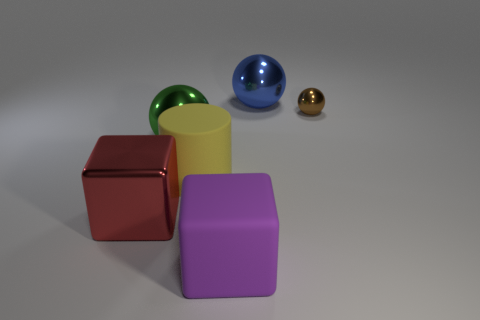How many blocks are either big things or yellow metal things?
Offer a terse response. 2. Is there any other thing that has the same color as the rubber block?
Make the answer very short. No. What is the cube right of the large matte object behind the big purple cube made of?
Your response must be concise. Rubber. Are the big purple cube and the large blue ball to the right of the large shiny block made of the same material?
Your answer should be compact. No. How many things are either large blocks to the left of the green sphere or big blue objects?
Make the answer very short. 2. Is there a matte cylinder of the same color as the large shiny cube?
Give a very brief answer. No. There is a red object; does it have the same shape as the metallic thing right of the big blue object?
Your answer should be very brief. No. What number of things are both right of the big blue metallic sphere and in front of the red thing?
Your answer should be very brief. 0. There is a purple thing that is the same shape as the large red thing; what is it made of?
Your response must be concise. Rubber. There is a brown metal thing that is behind the block right of the red shiny object; what size is it?
Offer a terse response. Small. 